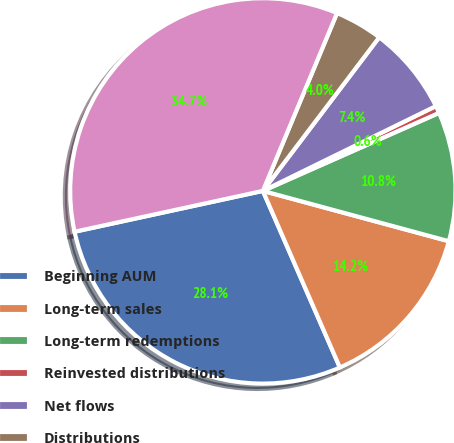Convert chart. <chart><loc_0><loc_0><loc_500><loc_500><pie_chart><fcel>Beginning AUM<fcel>Long-term sales<fcel>Long-term redemptions<fcel>Reinvested distributions<fcel>Net flows<fcel>Distributions<fcel>Ending AUM<nl><fcel>28.15%<fcel>14.25%<fcel>10.84%<fcel>0.62%<fcel>7.43%<fcel>4.03%<fcel>34.69%<nl></chart> 